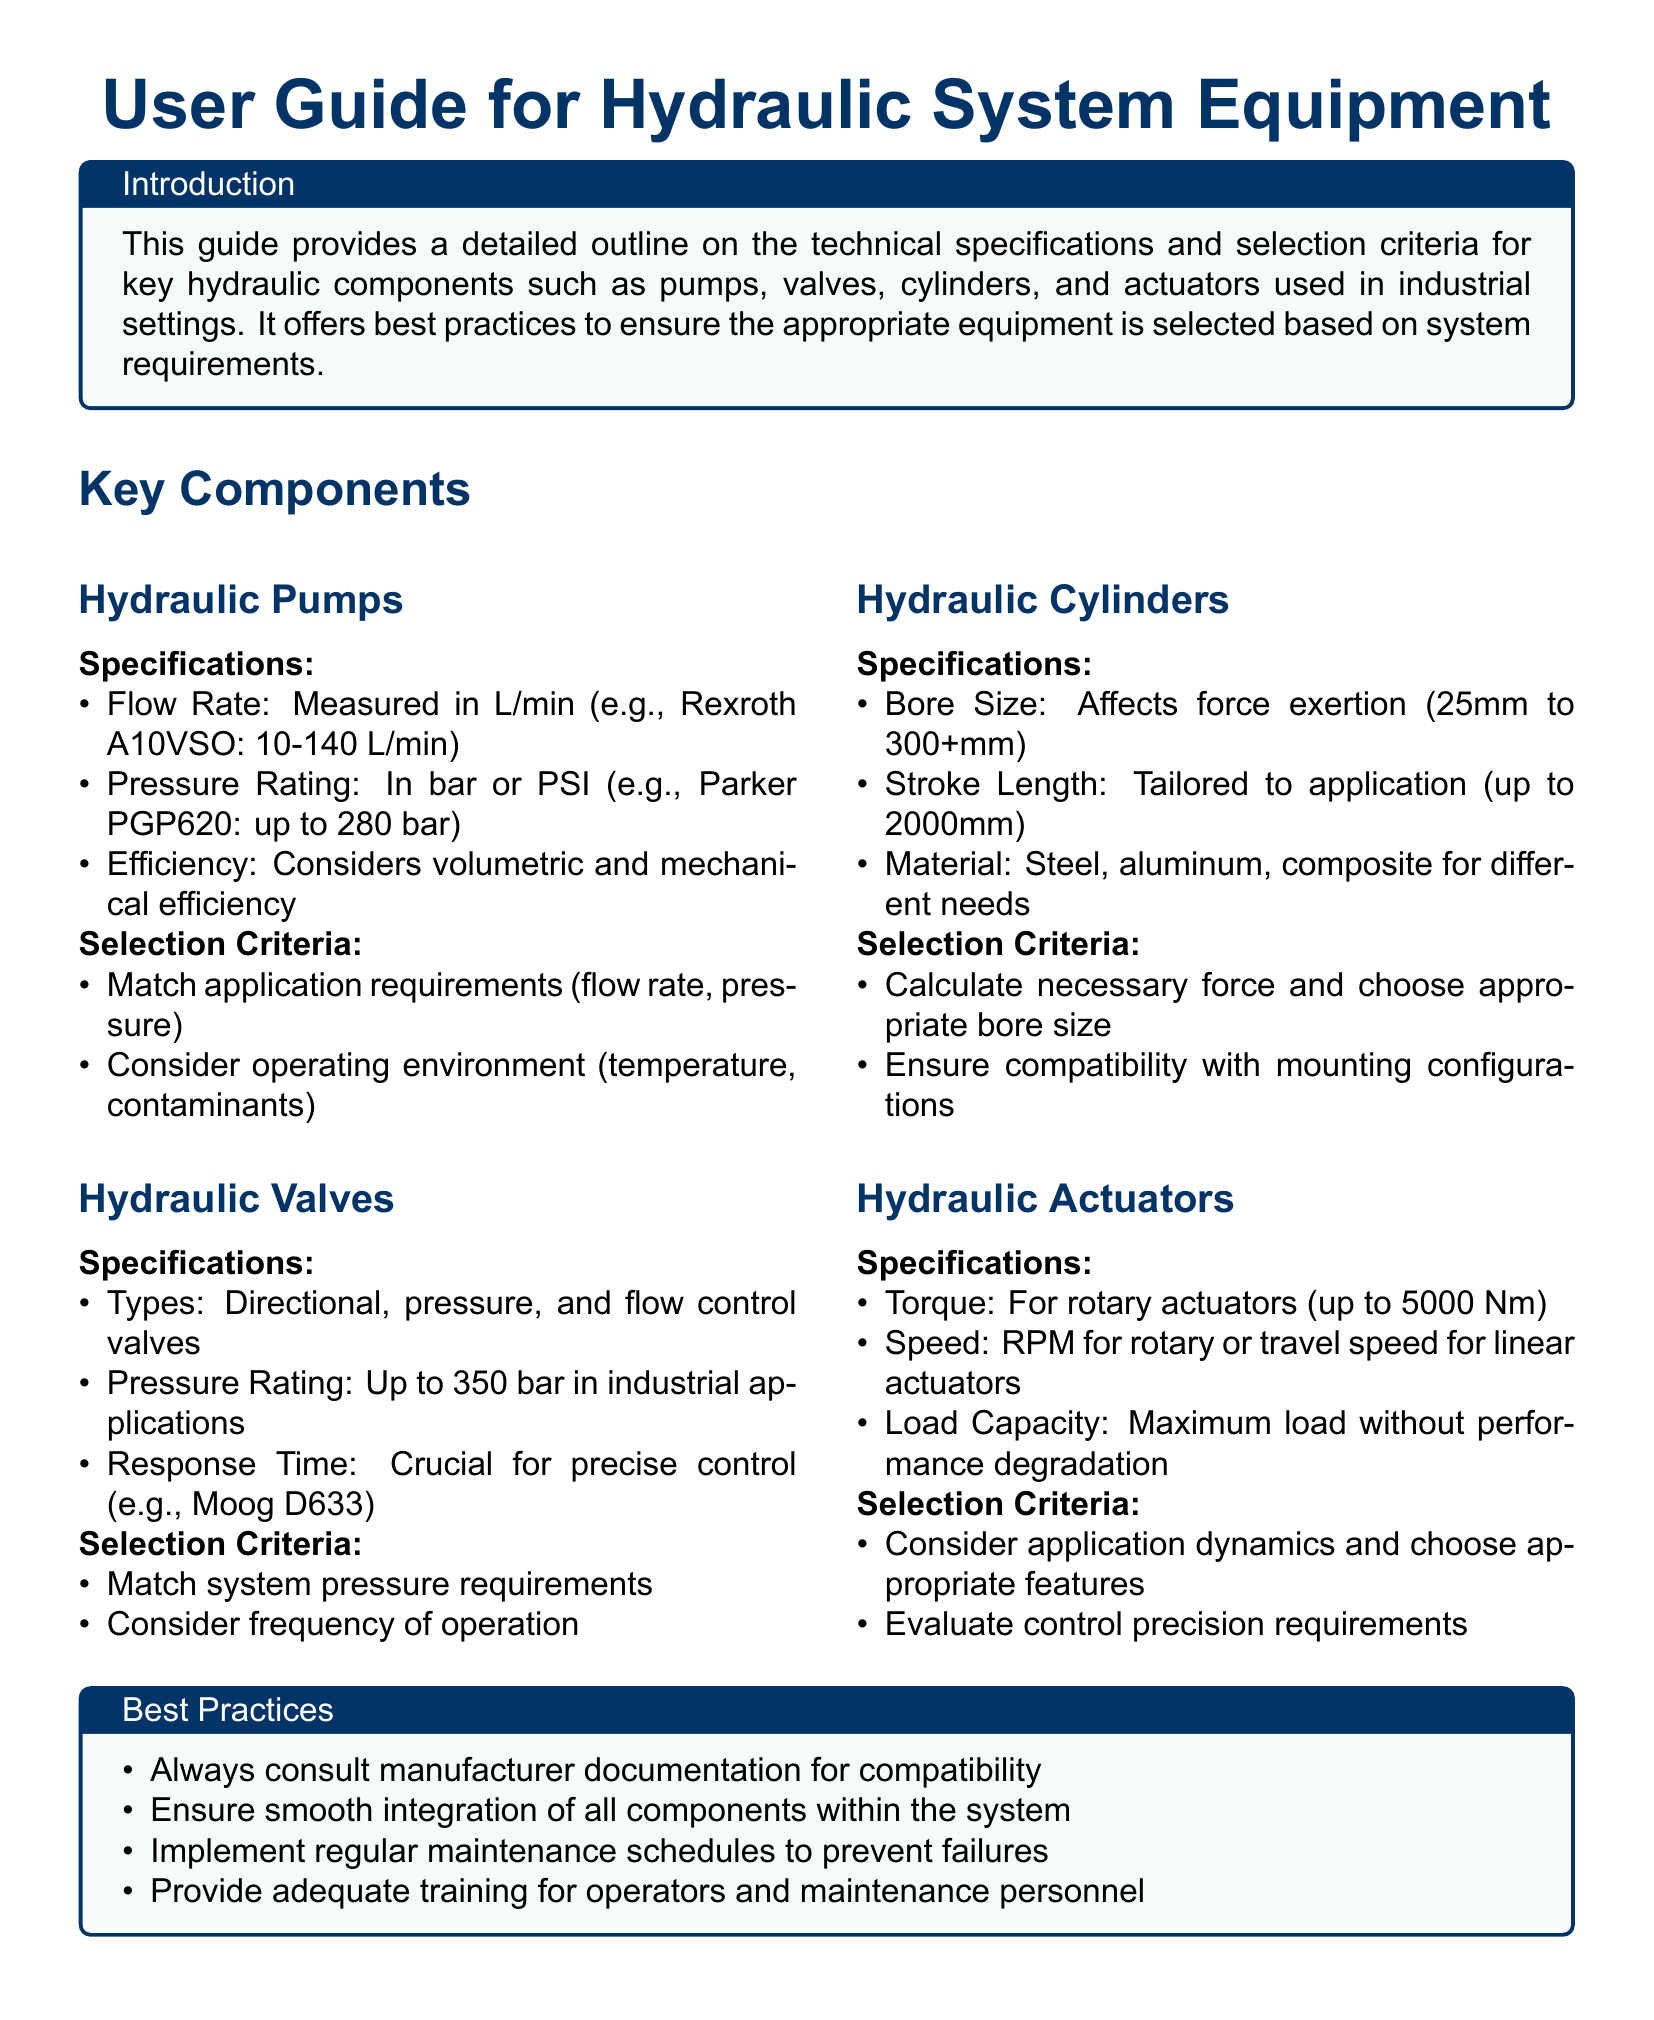What are the three key components discussed in the guide? The key components mentioned in the guide are pumps, valves, cylinders, and actuators.
Answer: Pumps, Valves, Cylinders, Actuators What is the bore size range for hydraulic cylinders? The document specifies that bore sizes range from 25 mm to over 300 mm.
Answer: 25 mm to 300+ mm What is the maximum torque for hydraulic actuators mentioned? The maximum torque for hydraulic actuators is stated as up to 5000 Nm.
Answer: 5000 Nm What should be matched to application requirements for hydraulic pumps? The guide indicates that flow rate and pressure should match application requirements.
Answer: Flow rate, pressure Which type of hydraulic valve has a response time that is crucial for control? The document specifically mentions directional, pressure, and flow control valves, highlighting the importance of response time.
Answer: Directional, pressure, flow control valves What is the pressure rating for hydraulic valves in industrial applications? The pressure rating specified for hydraulic valves is up to 350 bar.
Answer: Up to 350 bar What are the two types of considerations when selecting hydraulic pumps? The considerations include matching application requirements and considering the operating environment.
Answer: Application requirements, operating environment Which material options are provided for hydraulic cylinders? The guide lists steel, aluminum, and composite materials for hydraulic cylinders.
Answer: Steel, aluminum, composite What practice is emphasized for ensuring component integration? The document emphasizes the need to ensure smooth integration of all components within the system.
Answer: Smooth integration of components 